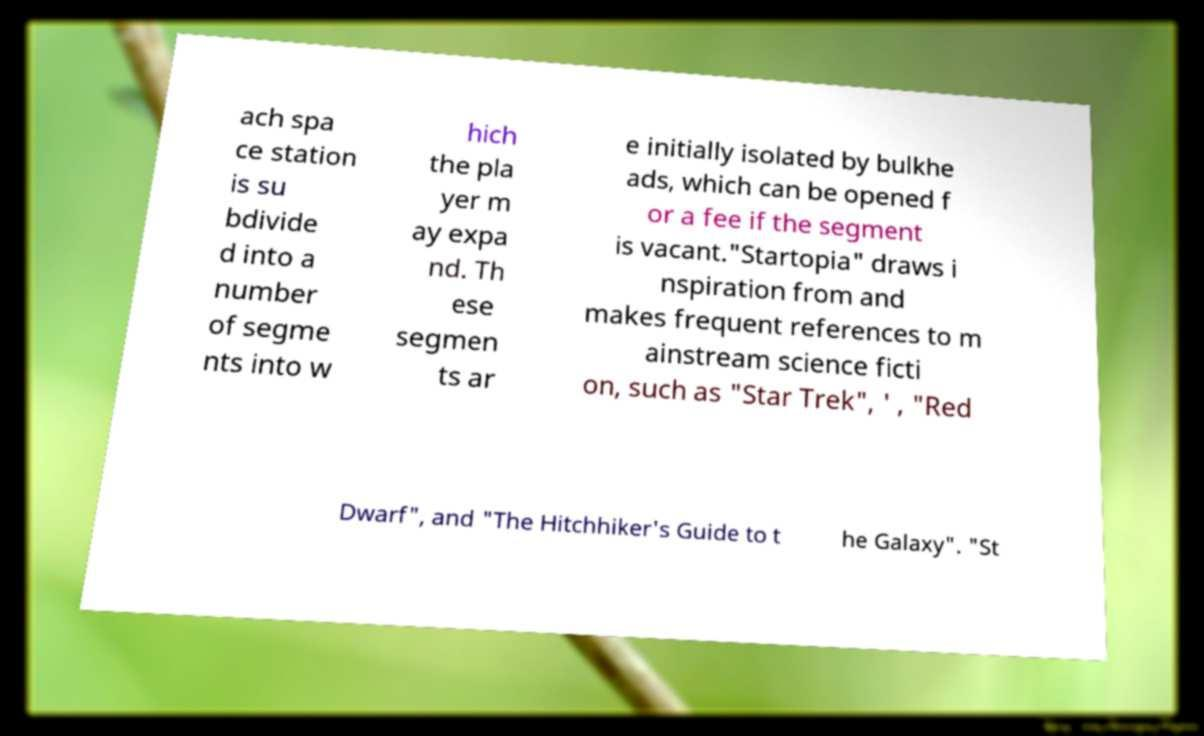Can you accurately transcribe the text from the provided image for me? ach spa ce station is su bdivide d into a number of segme nts into w hich the pla yer m ay expa nd. Th ese segmen ts ar e initially isolated by bulkhe ads, which can be opened f or a fee if the segment is vacant."Startopia" draws i nspiration from and makes frequent references to m ainstream science ficti on, such as "Star Trek", ' , "Red Dwarf", and "The Hitchhiker's Guide to t he Galaxy". "St 